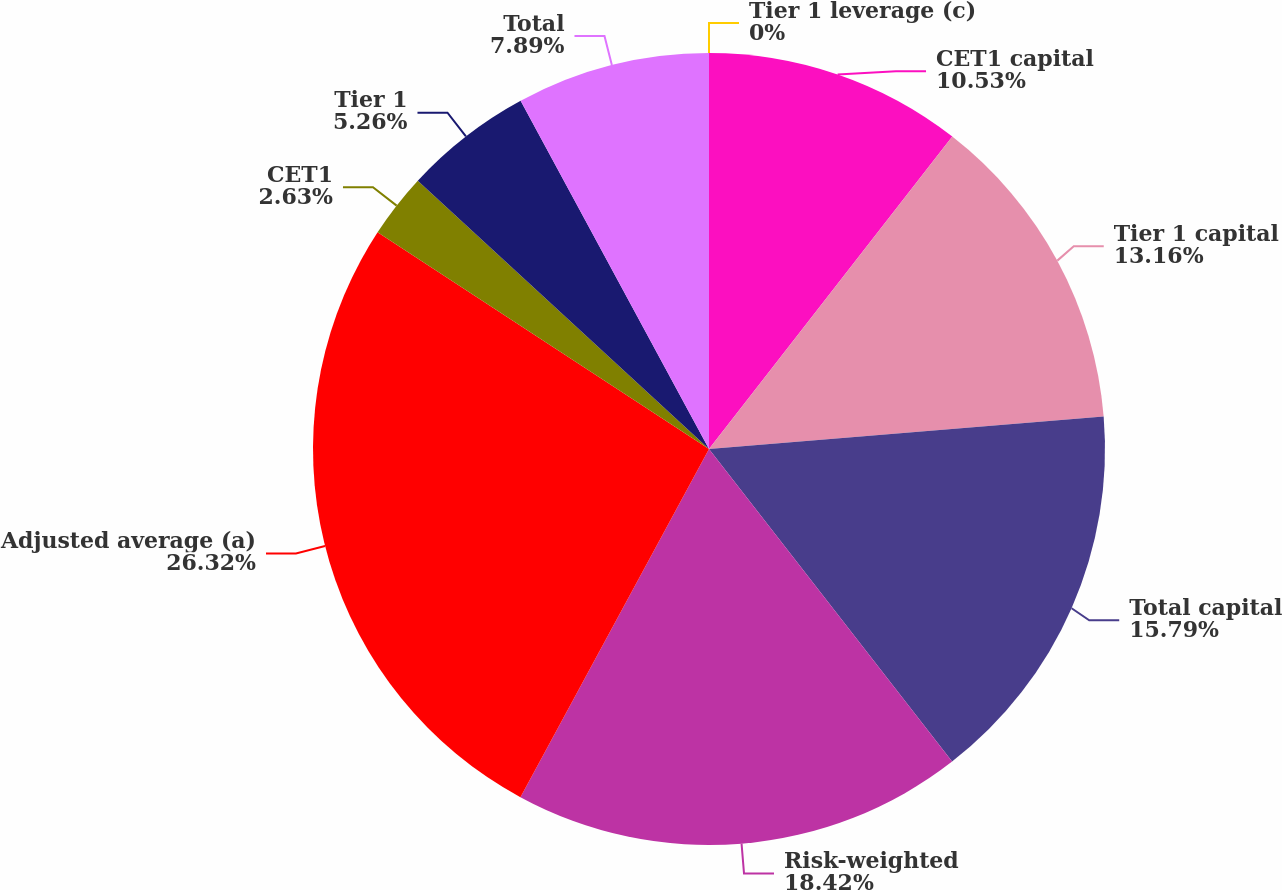Convert chart to OTSL. <chart><loc_0><loc_0><loc_500><loc_500><pie_chart><fcel>CET1 capital<fcel>Tier 1 capital<fcel>Total capital<fcel>Risk-weighted<fcel>Adjusted average (a)<fcel>CET1<fcel>Tier 1<fcel>Total<fcel>Tier 1 leverage (c)<nl><fcel>10.53%<fcel>13.16%<fcel>15.79%<fcel>18.42%<fcel>26.32%<fcel>2.63%<fcel>5.26%<fcel>7.89%<fcel>0.0%<nl></chart> 